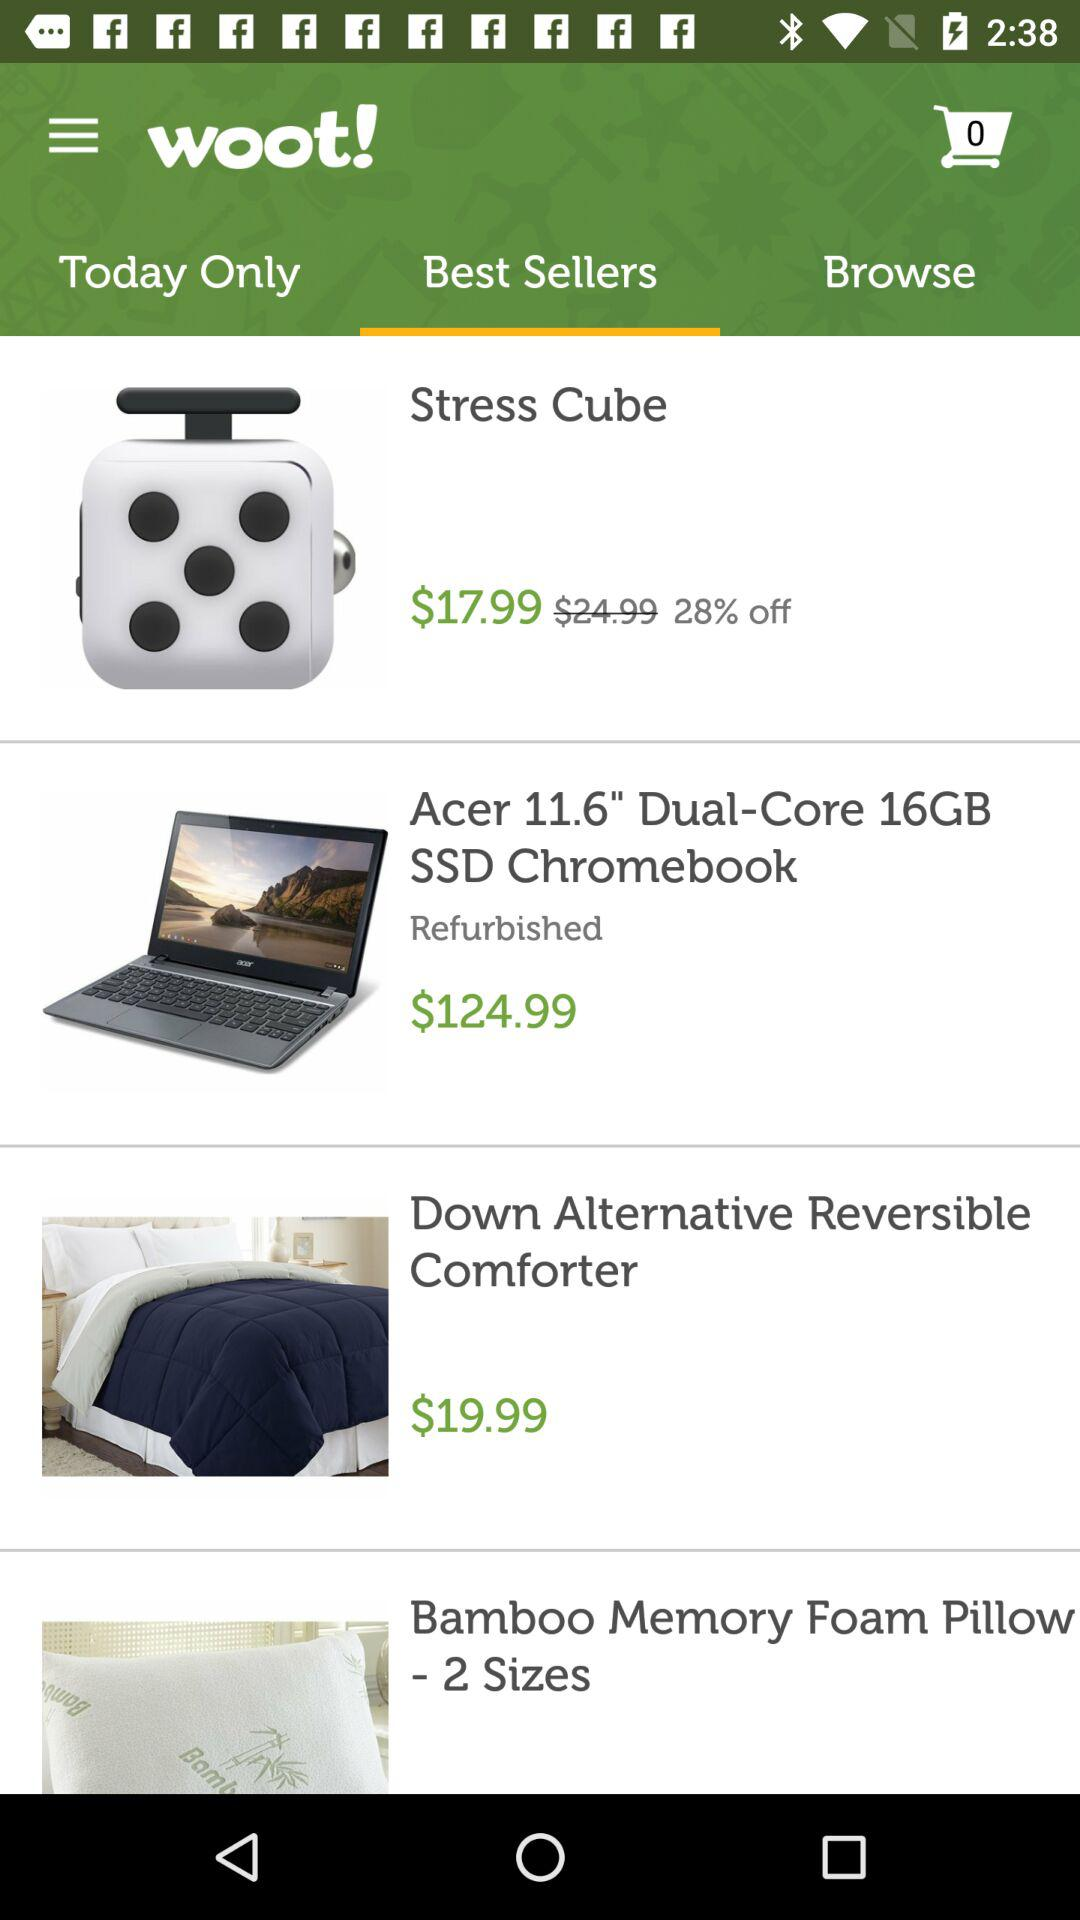How many items are displayed in the shopping cart? There is 0 item displayed in the shopping cart. 